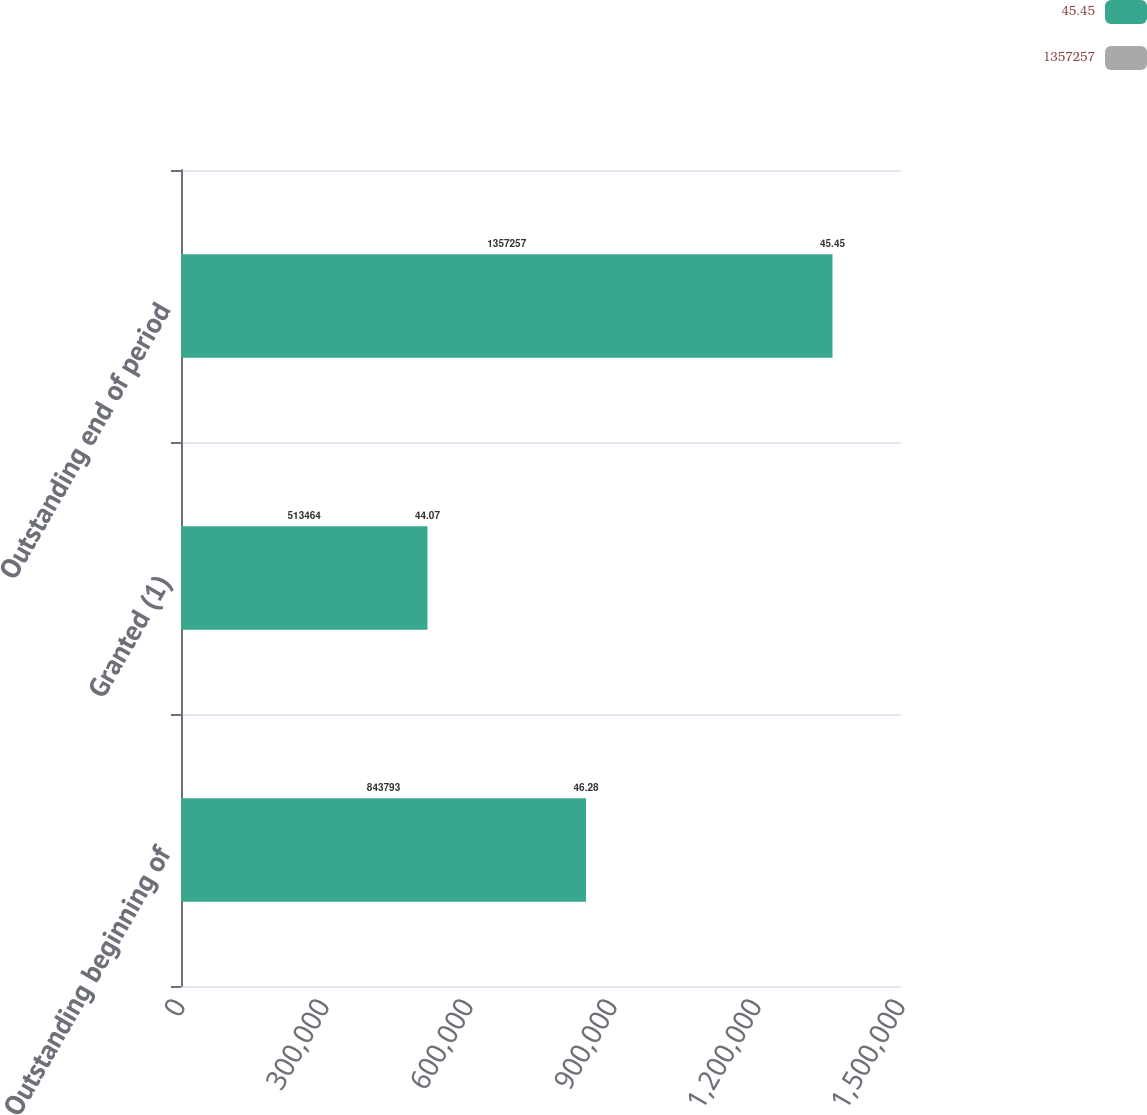<chart> <loc_0><loc_0><loc_500><loc_500><stacked_bar_chart><ecel><fcel>Outstanding beginning of<fcel>Granted (1)<fcel>Outstanding end of period<nl><fcel>45.45<fcel>843793<fcel>513464<fcel>1.35726e+06<nl><fcel>1.35726e+06<fcel>46.28<fcel>44.07<fcel>45.45<nl></chart> 